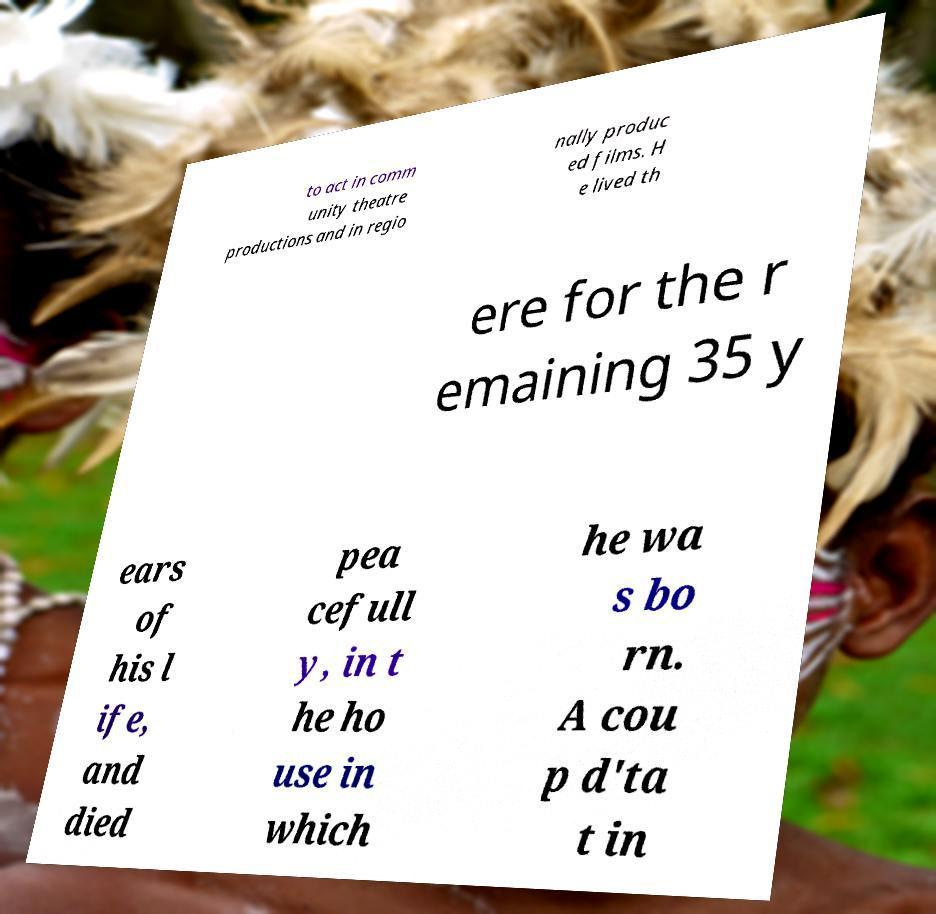For documentation purposes, I need the text within this image transcribed. Could you provide that? to act in comm unity theatre productions and in regio nally produc ed films. H e lived th ere for the r emaining 35 y ears of his l ife, and died pea cefull y, in t he ho use in which he wa s bo rn. A cou p d'ta t in 